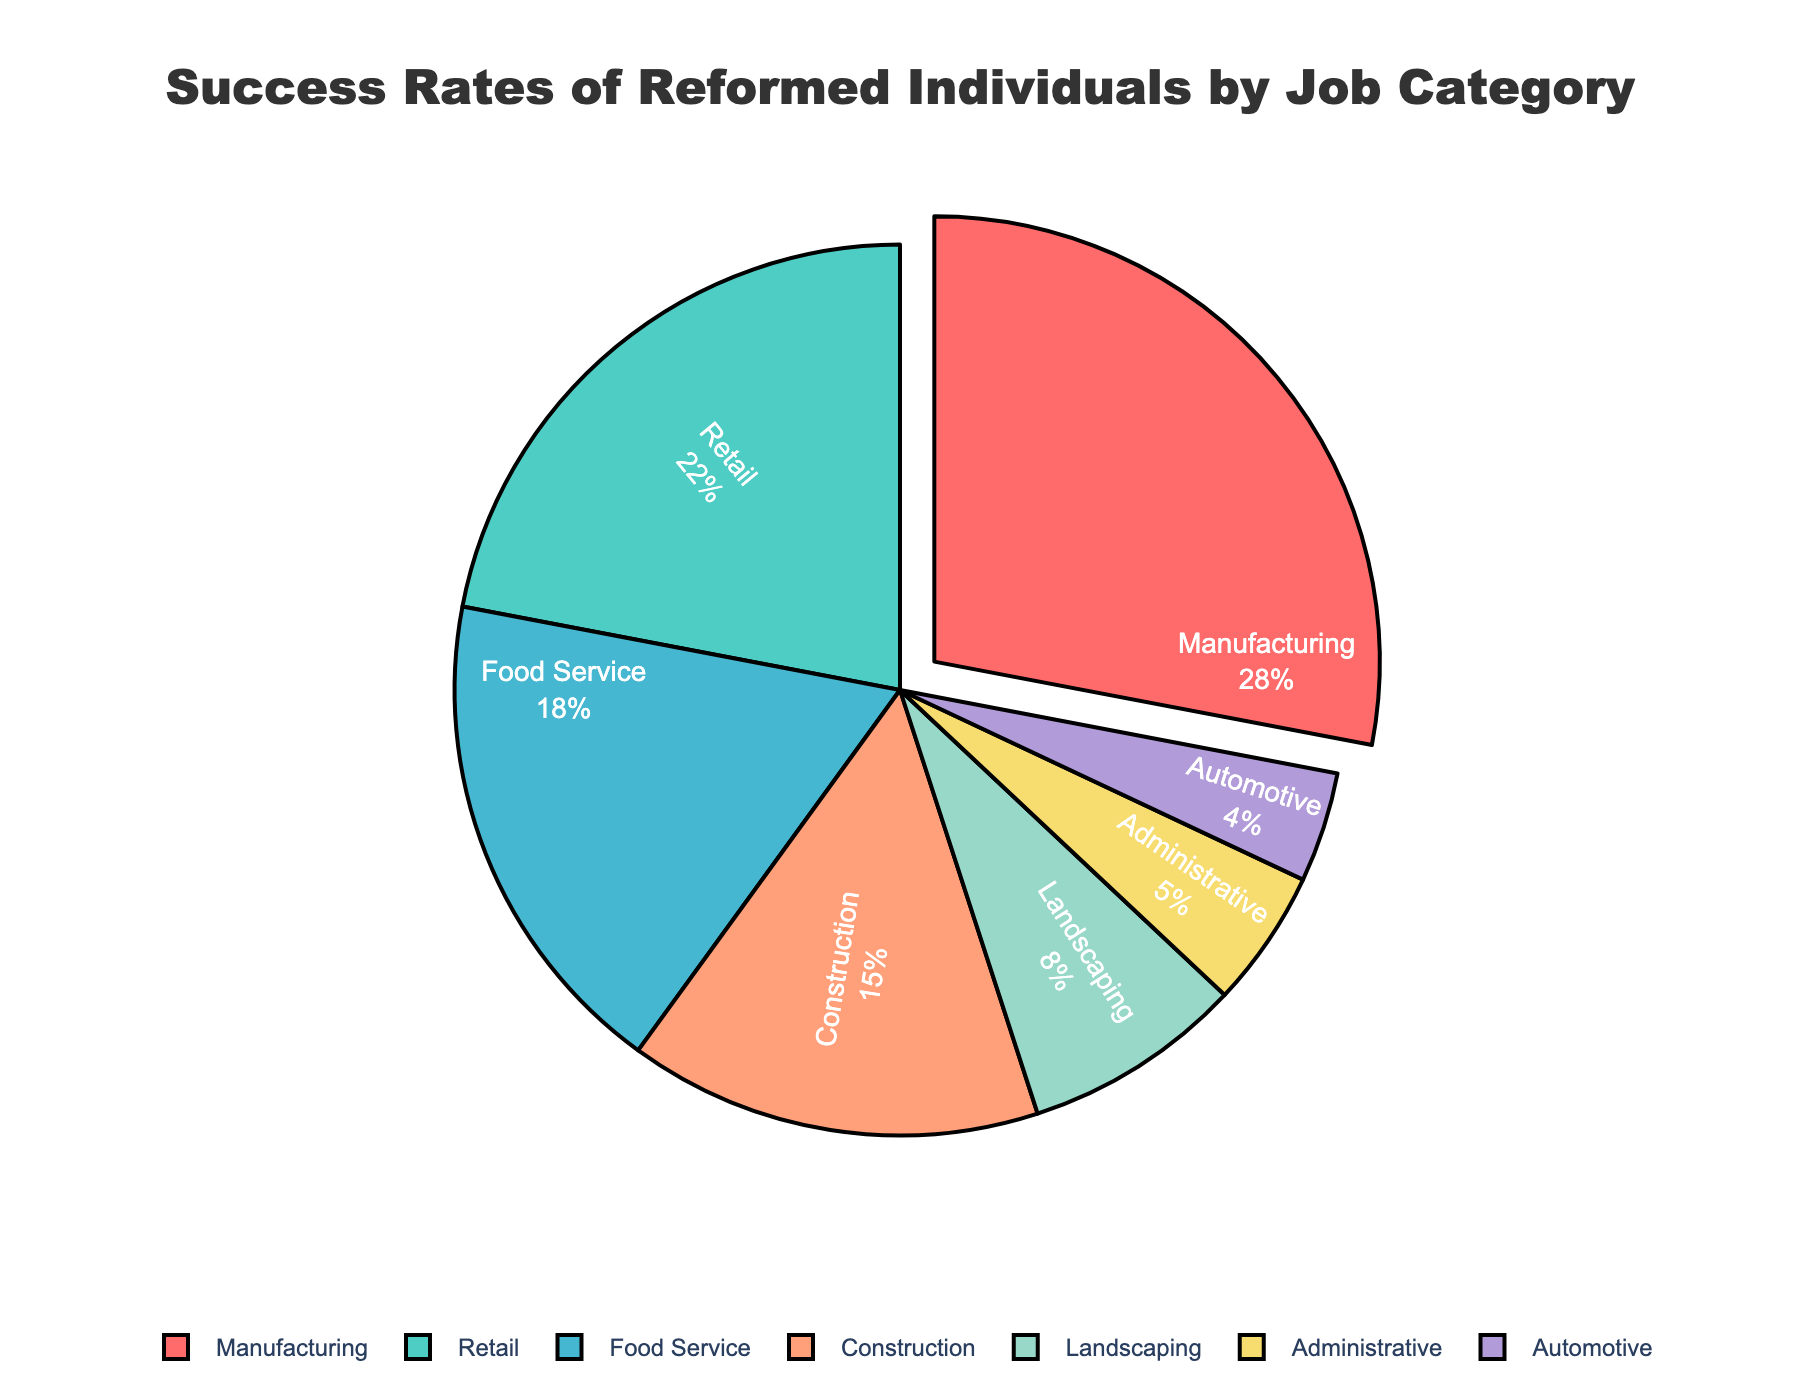Which job category has the highest success rate? The segment with the largest pull-out indicates the highest success rate. From the pie chart, the sector that is pulled out the most is Manufacturing.
Answer: Manufacturing How many job categories have a success rate less than 10%? Identify all the job segments below 10% in the pie chart. The categories with rates less than 10% are Landscaping, Administrative, and Automotive, totaling 3.
Answer: 3 What is the combined success rate of Retail and Food Service? Sum the percentages of Retail (22%) and Food Service (18%) from the chart. 22% + 18% = 40%.
Answer: 40% Which job category has the smallest success rate? The smallest segment in the pie chart represents the lowest success rate. The smallest segment is Automotive.
Answer: Automotive Is the success rate of Construction higher or lower than Landscaping? Compare the sizes of the Construction and Landscaping segments. Construction has a success rate of 15% and Landscaping has a rate of 8%, so Construction is higher.
Answer: Higher What is the difference in success rate between Manufacturing and Automotive? Subtract the success rate of Automotive (4%) from Manufacturing (28%). 28% - 4% = 24%.
Answer: 24% Is the success rate of Food Service closer to Retail or Construction? Compare the differences in success rates: Food Service (18%) to Retail (22%) is 4%, while Food Service to Construction (15%) is 3%. The smaller difference is between Food Service and Construction.
Answer: Construction What percentage of job categories have success rates of 20% or more? Count the segments meeting this criteria: Manufacturing (28%) and Retail (22%), which are 2 out of 7 total categories. (2/7) * 100% = Approximately 28.57%.
Answer: Approximately 28.57% If the success rates of Administrative and Automotive were combined, would their total rate be higher than Food Service? Add the success rates: Administrative (5%) + Automotive (4%) = 9%. Compare this to Food Service's 18%. 18% > 9%, so it would not be higher.
Answer: No What is the average success rate across all job categories? Sum all the success rates and divide by the number of categories: (28 + 22 + 18 + 15 + 8 + 5 + 4)/7. The sum is 100, so 100/7 ≈ 14.29%.
Answer: Approximately 14.29% 